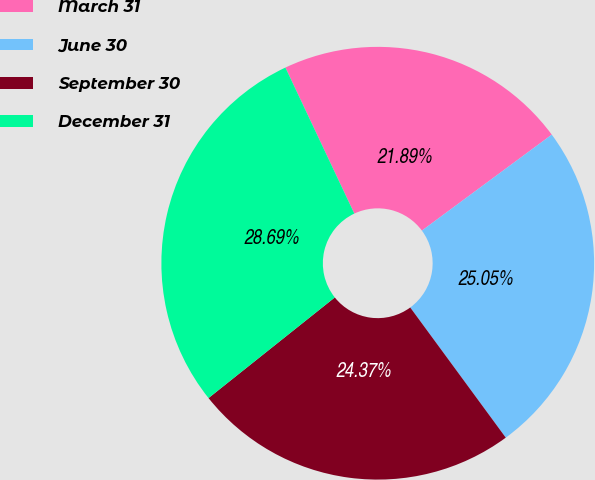Convert chart. <chart><loc_0><loc_0><loc_500><loc_500><pie_chart><fcel>March 31<fcel>June 30<fcel>September 30<fcel>December 31<nl><fcel>21.89%<fcel>25.05%<fcel>24.37%<fcel>28.69%<nl></chart> 